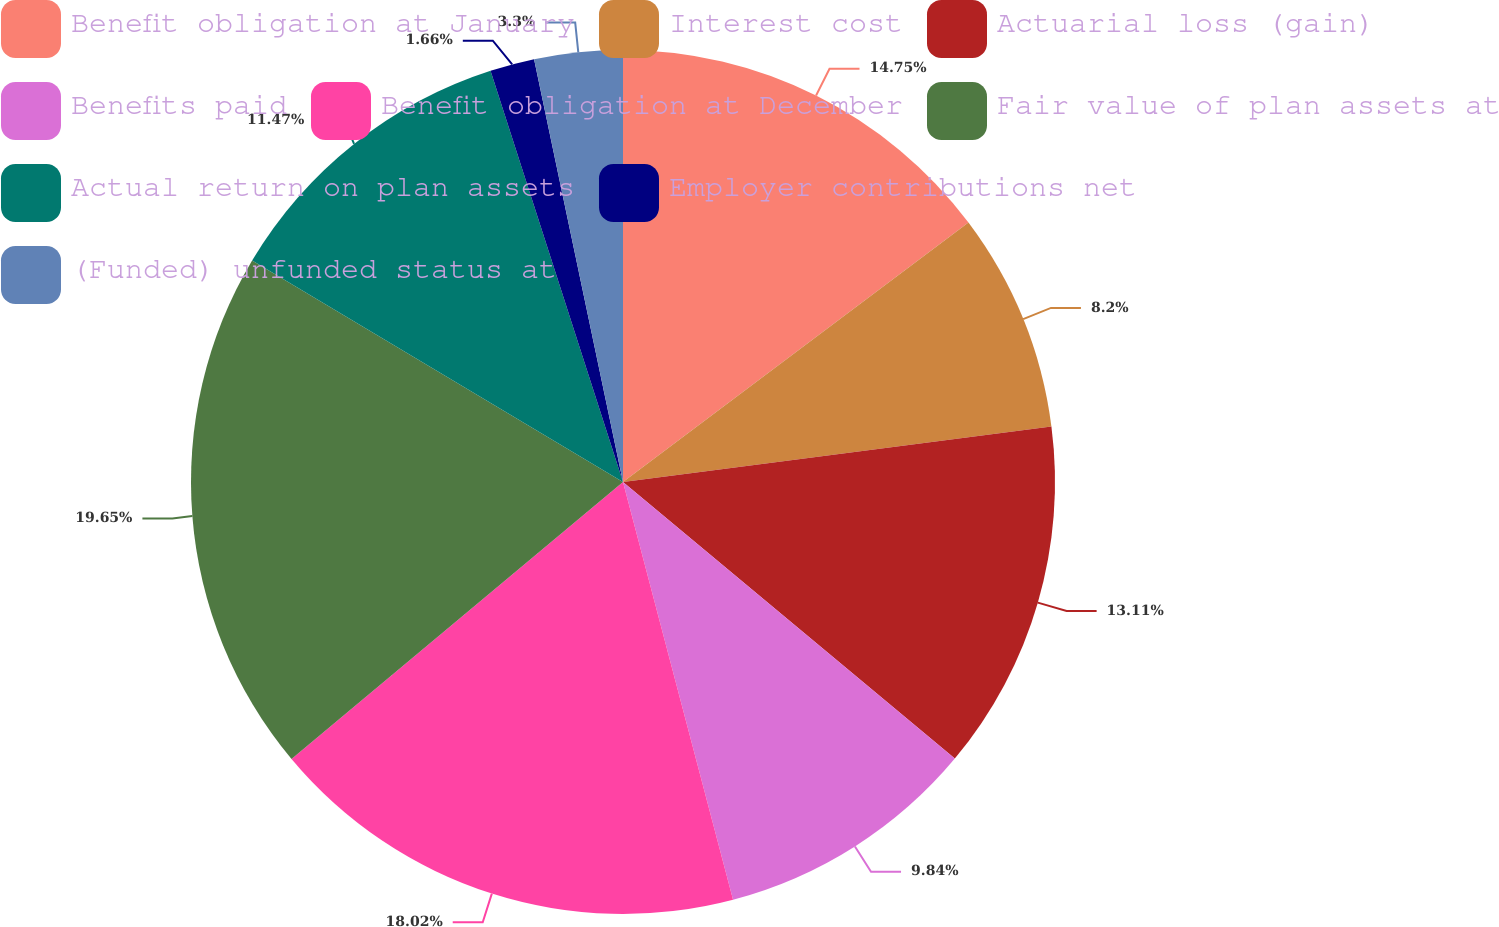Convert chart to OTSL. <chart><loc_0><loc_0><loc_500><loc_500><pie_chart><fcel>Benefit obligation at January<fcel>Interest cost<fcel>Actuarial loss (gain)<fcel>Benefits paid<fcel>Benefit obligation at December<fcel>Fair value of plan assets at<fcel>Actual return on plan assets<fcel>Employer contributions net<fcel>(Funded) unfunded status at<nl><fcel>14.75%<fcel>8.2%<fcel>13.11%<fcel>9.84%<fcel>18.02%<fcel>19.65%<fcel>11.47%<fcel>1.66%<fcel>3.3%<nl></chart> 